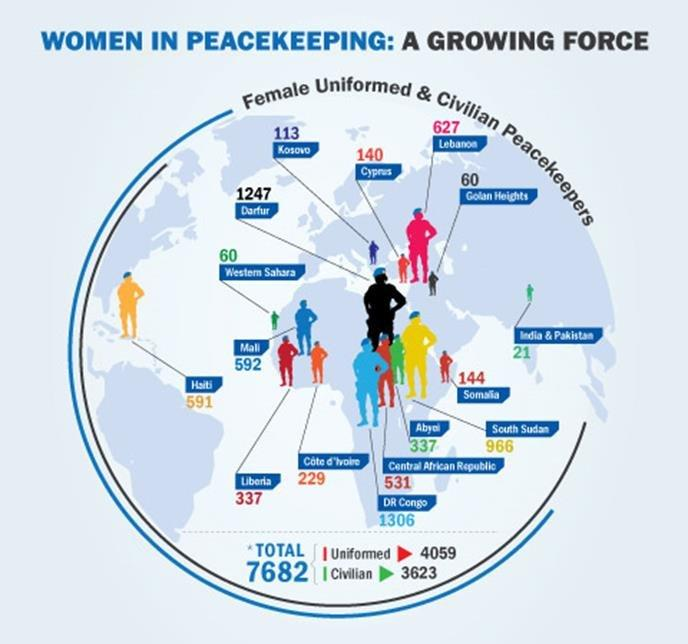Indicate a few pertinent items in this graphic. There are a total of 732 female uniformed and civilian peacekeepers in Mali and Cyprus combined. 